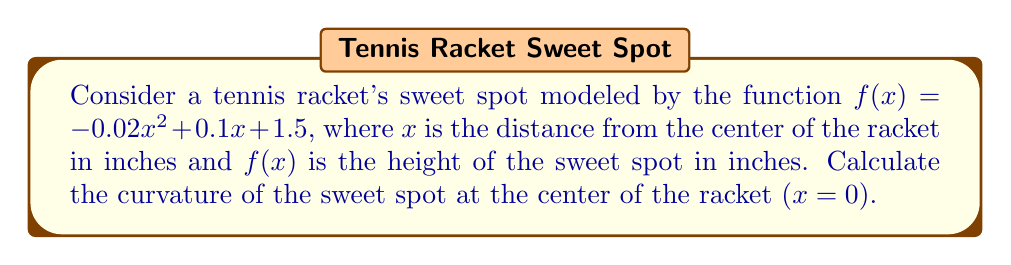Teach me how to tackle this problem. To find the curvature of the sweet spot, we'll use the curvature formula for a function $y = f(x)$:

$$\kappa = \frac{|f''(x)|}{(1 + [f'(x)]^2)^{3/2}}$$

Step 1: Find $f'(x)$ and $f''(x)$
$f'(x) = -0.04x + 0.1$
$f''(x) = -0.04$

Step 2: Evaluate $f'(x)$ at $x = 0$
$f'(0) = 0.1$

Step 3: Substitute values into the curvature formula
$$\kappa = \frac{|-0.04|}{(1 + [0.1]^2)^{3/2}}$$

Step 4: Simplify
$$\kappa = \frac{0.04}{(1 + 0.01)^{3/2}} = \frac{0.04}{(1.01)^{3/2}}$$

Step 5: Calculate the final result
$$\kappa \approx 0.0396$$
Answer: $0.0396$ 